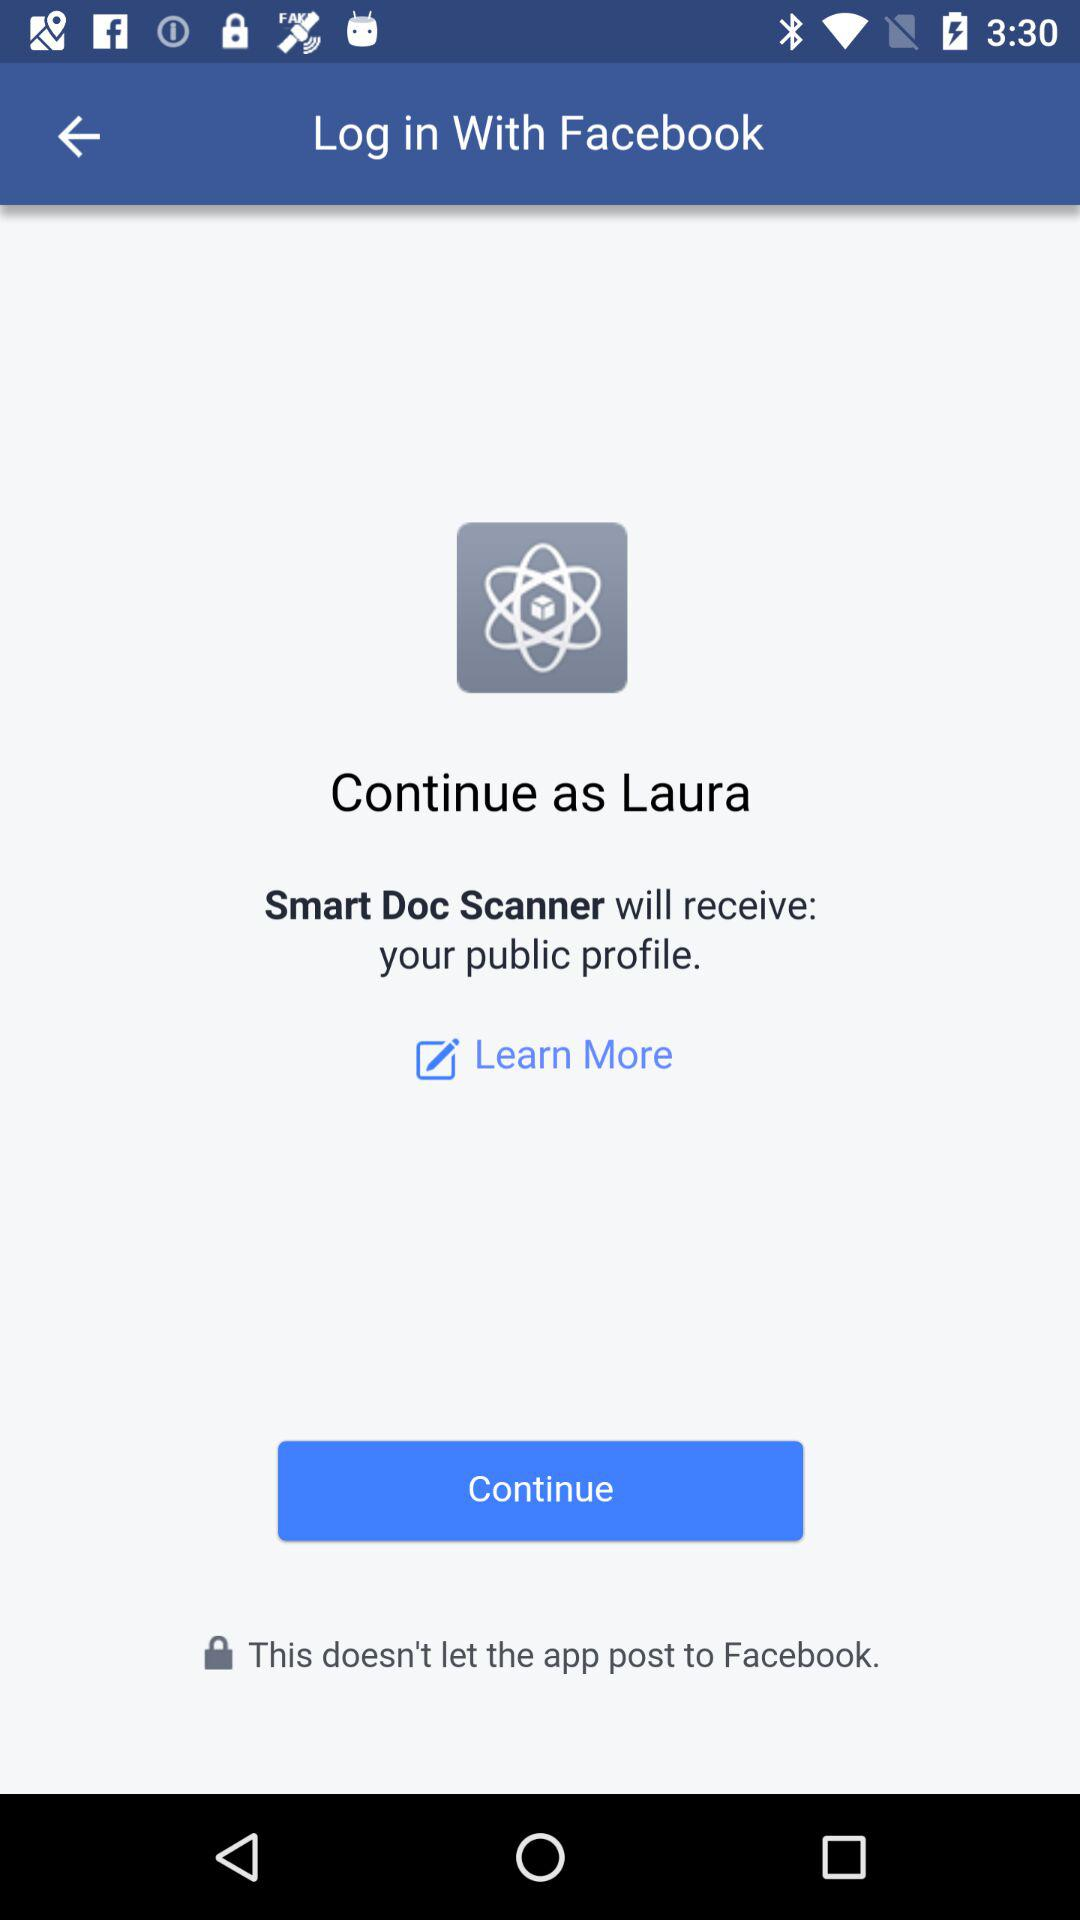What app can be used to log in? The app that can be used to log in is "Facebook". 